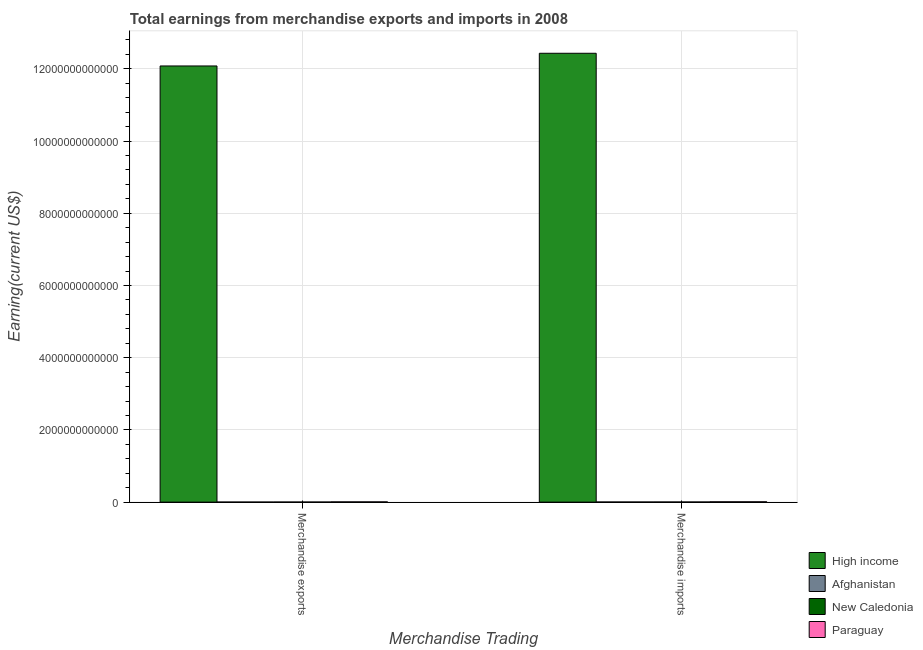How many different coloured bars are there?
Offer a terse response. 4. What is the earnings from merchandise imports in Paraguay?
Give a very brief answer. 9.03e+09. Across all countries, what is the maximum earnings from merchandise imports?
Your answer should be compact. 1.24e+13. Across all countries, what is the minimum earnings from merchandise imports?
Offer a terse response. 3.02e+09. In which country was the earnings from merchandise exports minimum?
Your answer should be very brief. Afghanistan. What is the total earnings from merchandise exports in the graph?
Your answer should be very brief. 1.21e+13. What is the difference between the earnings from merchandise imports in Afghanistan and that in New Caledonia?
Offer a terse response. -2.13e+08. What is the difference between the earnings from merchandise imports in High income and the earnings from merchandise exports in New Caledonia?
Make the answer very short. 1.24e+13. What is the average earnings from merchandise imports per country?
Make the answer very short. 3.11e+12. What is the difference between the earnings from merchandise imports and earnings from merchandise exports in New Caledonia?
Your answer should be compact. 1.93e+09. What is the ratio of the earnings from merchandise exports in Afghanistan to that in Paraguay?
Your answer should be compact. 0.08. What does the 1st bar from the left in Merchandise imports represents?
Provide a short and direct response. High income. What does the 3rd bar from the right in Merchandise imports represents?
Your response must be concise. Afghanistan. How many countries are there in the graph?
Your response must be concise. 4. What is the difference between two consecutive major ticks on the Y-axis?
Keep it short and to the point. 2.00e+12. Where does the legend appear in the graph?
Provide a short and direct response. Bottom right. How many legend labels are there?
Provide a succinct answer. 4. How are the legend labels stacked?
Keep it short and to the point. Vertical. What is the title of the graph?
Make the answer very short. Total earnings from merchandise exports and imports in 2008. Does "Ecuador" appear as one of the legend labels in the graph?
Offer a very short reply. No. What is the label or title of the X-axis?
Make the answer very short. Merchandise Trading. What is the label or title of the Y-axis?
Keep it short and to the point. Earning(current US$). What is the Earning(current US$) in High income in Merchandise exports?
Keep it short and to the point. 1.21e+13. What is the Earning(current US$) of Afghanistan in Merchandise exports?
Keep it short and to the point. 5.40e+08. What is the Earning(current US$) in New Caledonia in Merchandise exports?
Make the answer very short. 1.30e+09. What is the Earning(current US$) of Paraguay in Merchandise exports?
Your response must be concise. 6.41e+09. What is the Earning(current US$) in High income in Merchandise imports?
Keep it short and to the point. 1.24e+13. What is the Earning(current US$) in Afghanistan in Merchandise imports?
Your response must be concise. 3.02e+09. What is the Earning(current US$) in New Caledonia in Merchandise imports?
Your answer should be compact. 3.23e+09. What is the Earning(current US$) of Paraguay in Merchandise imports?
Your response must be concise. 9.03e+09. Across all Merchandise Trading, what is the maximum Earning(current US$) in High income?
Provide a short and direct response. 1.24e+13. Across all Merchandise Trading, what is the maximum Earning(current US$) of Afghanistan?
Your answer should be compact. 3.02e+09. Across all Merchandise Trading, what is the maximum Earning(current US$) of New Caledonia?
Offer a terse response. 3.23e+09. Across all Merchandise Trading, what is the maximum Earning(current US$) in Paraguay?
Give a very brief answer. 9.03e+09. Across all Merchandise Trading, what is the minimum Earning(current US$) of High income?
Offer a terse response. 1.21e+13. Across all Merchandise Trading, what is the minimum Earning(current US$) in Afghanistan?
Your answer should be very brief. 5.40e+08. Across all Merchandise Trading, what is the minimum Earning(current US$) in New Caledonia?
Ensure brevity in your answer.  1.30e+09. Across all Merchandise Trading, what is the minimum Earning(current US$) of Paraguay?
Provide a succinct answer. 6.41e+09. What is the total Earning(current US$) of High income in the graph?
Make the answer very short. 2.45e+13. What is the total Earning(current US$) of Afghanistan in the graph?
Keep it short and to the point. 3.56e+09. What is the total Earning(current US$) in New Caledonia in the graph?
Your response must be concise. 4.53e+09. What is the total Earning(current US$) of Paraguay in the graph?
Offer a very short reply. 1.54e+1. What is the difference between the Earning(current US$) in High income in Merchandise exports and that in Merchandise imports?
Your answer should be compact. -3.52e+11. What is the difference between the Earning(current US$) of Afghanistan in Merchandise exports and that in Merchandise imports?
Offer a terse response. -2.48e+09. What is the difference between the Earning(current US$) of New Caledonia in Merchandise exports and that in Merchandise imports?
Offer a very short reply. -1.93e+09. What is the difference between the Earning(current US$) in Paraguay in Merchandise exports and that in Merchandise imports?
Provide a succinct answer. -2.63e+09. What is the difference between the Earning(current US$) in High income in Merchandise exports and the Earning(current US$) in Afghanistan in Merchandise imports?
Make the answer very short. 1.21e+13. What is the difference between the Earning(current US$) of High income in Merchandise exports and the Earning(current US$) of New Caledonia in Merchandise imports?
Ensure brevity in your answer.  1.21e+13. What is the difference between the Earning(current US$) in High income in Merchandise exports and the Earning(current US$) in Paraguay in Merchandise imports?
Give a very brief answer. 1.21e+13. What is the difference between the Earning(current US$) in Afghanistan in Merchandise exports and the Earning(current US$) in New Caledonia in Merchandise imports?
Your response must be concise. -2.69e+09. What is the difference between the Earning(current US$) of Afghanistan in Merchandise exports and the Earning(current US$) of Paraguay in Merchandise imports?
Your answer should be compact. -8.49e+09. What is the difference between the Earning(current US$) of New Caledonia in Merchandise exports and the Earning(current US$) of Paraguay in Merchandise imports?
Provide a succinct answer. -7.73e+09. What is the average Earning(current US$) of High income per Merchandise Trading?
Offer a terse response. 1.23e+13. What is the average Earning(current US$) in Afghanistan per Merchandise Trading?
Provide a succinct answer. 1.78e+09. What is the average Earning(current US$) in New Caledonia per Merchandise Trading?
Keep it short and to the point. 2.27e+09. What is the average Earning(current US$) in Paraguay per Merchandise Trading?
Your response must be concise. 7.72e+09. What is the difference between the Earning(current US$) in High income and Earning(current US$) in Afghanistan in Merchandise exports?
Your response must be concise. 1.21e+13. What is the difference between the Earning(current US$) of High income and Earning(current US$) of New Caledonia in Merchandise exports?
Make the answer very short. 1.21e+13. What is the difference between the Earning(current US$) in High income and Earning(current US$) in Paraguay in Merchandise exports?
Provide a succinct answer. 1.21e+13. What is the difference between the Earning(current US$) of Afghanistan and Earning(current US$) of New Caledonia in Merchandise exports?
Offer a very short reply. -7.60e+08. What is the difference between the Earning(current US$) in Afghanistan and Earning(current US$) in Paraguay in Merchandise exports?
Your answer should be compact. -5.87e+09. What is the difference between the Earning(current US$) in New Caledonia and Earning(current US$) in Paraguay in Merchandise exports?
Provide a succinct answer. -5.11e+09. What is the difference between the Earning(current US$) of High income and Earning(current US$) of Afghanistan in Merchandise imports?
Provide a short and direct response. 1.24e+13. What is the difference between the Earning(current US$) in High income and Earning(current US$) in New Caledonia in Merchandise imports?
Your answer should be very brief. 1.24e+13. What is the difference between the Earning(current US$) of High income and Earning(current US$) of Paraguay in Merchandise imports?
Offer a terse response. 1.24e+13. What is the difference between the Earning(current US$) in Afghanistan and Earning(current US$) in New Caledonia in Merchandise imports?
Your response must be concise. -2.13e+08. What is the difference between the Earning(current US$) of Afghanistan and Earning(current US$) of Paraguay in Merchandise imports?
Your response must be concise. -6.01e+09. What is the difference between the Earning(current US$) in New Caledonia and Earning(current US$) in Paraguay in Merchandise imports?
Give a very brief answer. -5.80e+09. What is the ratio of the Earning(current US$) of High income in Merchandise exports to that in Merchandise imports?
Your answer should be compact. 0.97. What is the ratio of the Earning(current US$) in Afghanistan in Merchandise exports to that in Merchandise imports?
Provide a succinct answer. 0.18. What is the ratio of the Earning(current US$) of New Caledonia in Merchandise exports to that in Merchandise imports?
Offer a very short reply. 0.4. What is the ratio of the Earning(current US$) of Paraguay in Merchandise exports to that in Merchandise imports?
Make the answer very short. 0.71. What is the difference between the highest and the second highest Earning(current US$) of High income?
Ensure brevity in your answer.  3.52e+11. What is the difference between the highest and the second highest Earning(current US$) of Afghanistan?
Ensure brevity in your answer.  2.48e+09. What is the difference between the highest and the second highest Earning(current US$) of New Caledonia?
Offer a very short reply. 1.93e+09. What is the difference between the highest and the second highest Earning(current US$) in Paraguay?
Provide a succinct answer. 2.63e+09. What is the difference between the highest and the lowest Earning(current US$) of High income?
Offer a terse response. 3.52e+11. What is the difference between the highest and the lowest Earning(current US$) in Afghanistan?
Make the answer very short. 2.48e+09. What is the difference between the highest and the lowest Earning(current US$) of New Caledonia?
Your response must be concise. 1.93e+09. What is the difference between the highest and the lowest Earning(current US$) of Paraguay?
Your answer should be very brief. 2.63e+09. 